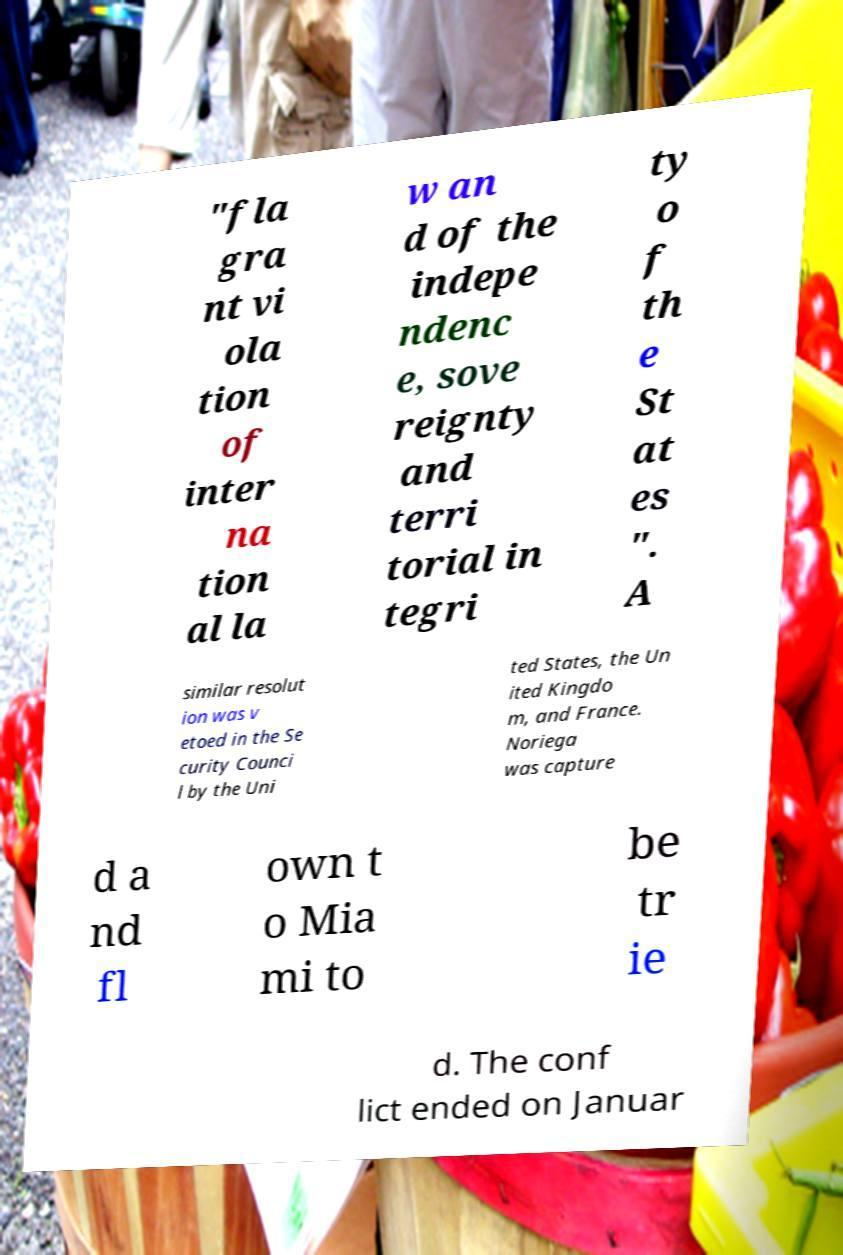Could you assist in decoding the text presented in this image and type it out clearly? "fla gra nt vi ola tion of inter na tion al la w an d of the indepe ndenc e, sove reignty and terri torial in tegri ty o f th e St at es ". A similar resolut ion was v etoed in the Se curity Counci l by the Uni ted States, the Un ited Kingdo m, and France. Noriega was capture d a nd fl own t o Mia mi to be tr ie d. The conf lict ended on Januar 